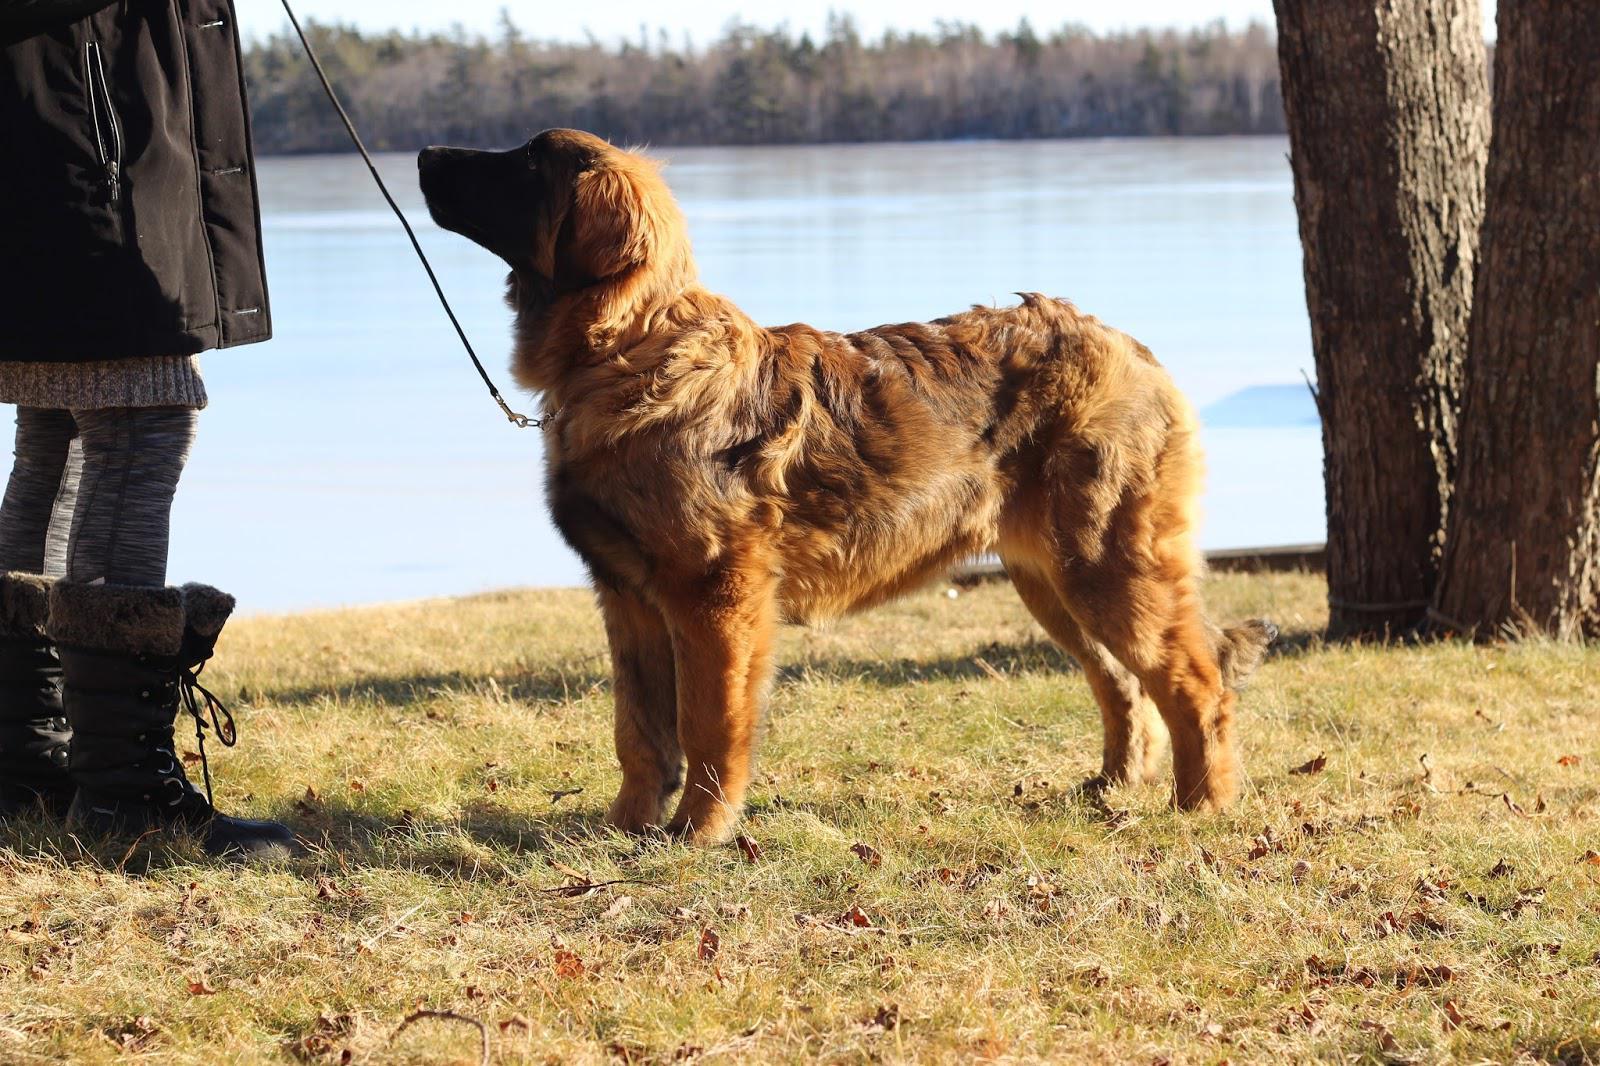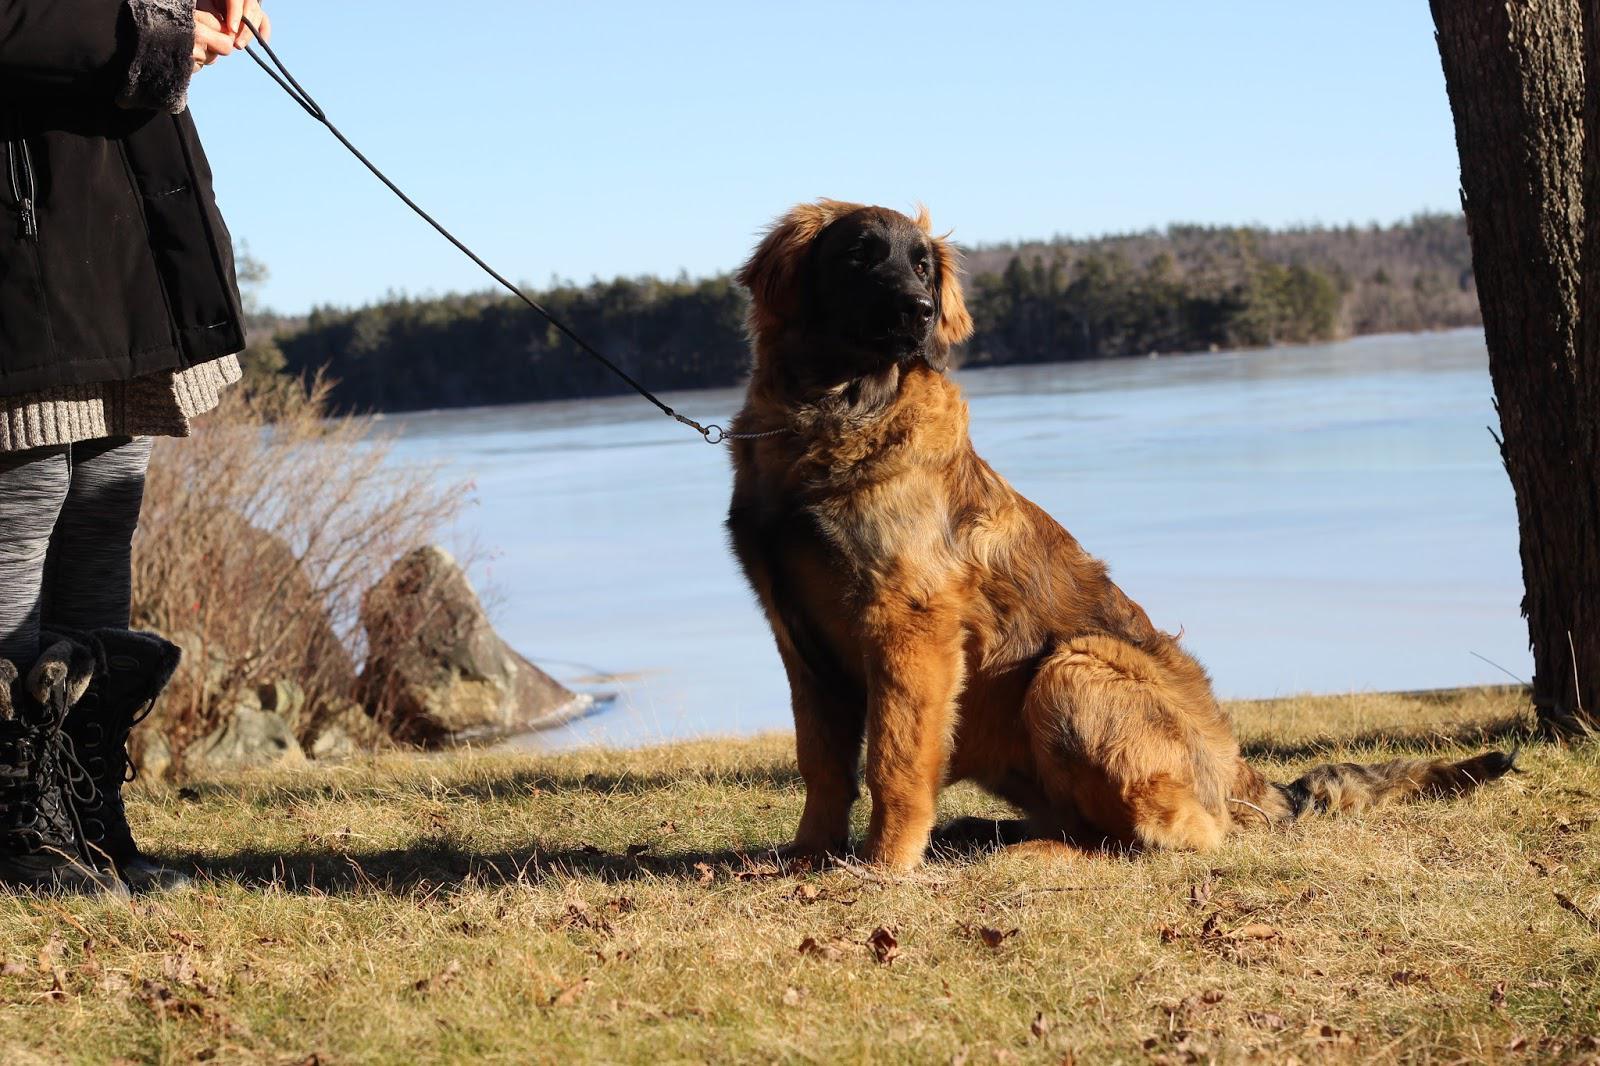The first image is the image on the left, the second image is the image on the right. For the images shown, is this caption "There are three dogs in the pair of images." true? Answer yes or no. No. The first image is the image on the left, the second image is the image on the right. For the images shown, is this caption "A blue plastic plaything of some type is on the grass in one of the images featuring a big brownish-orange dog." true? Answer yes or no. No. 